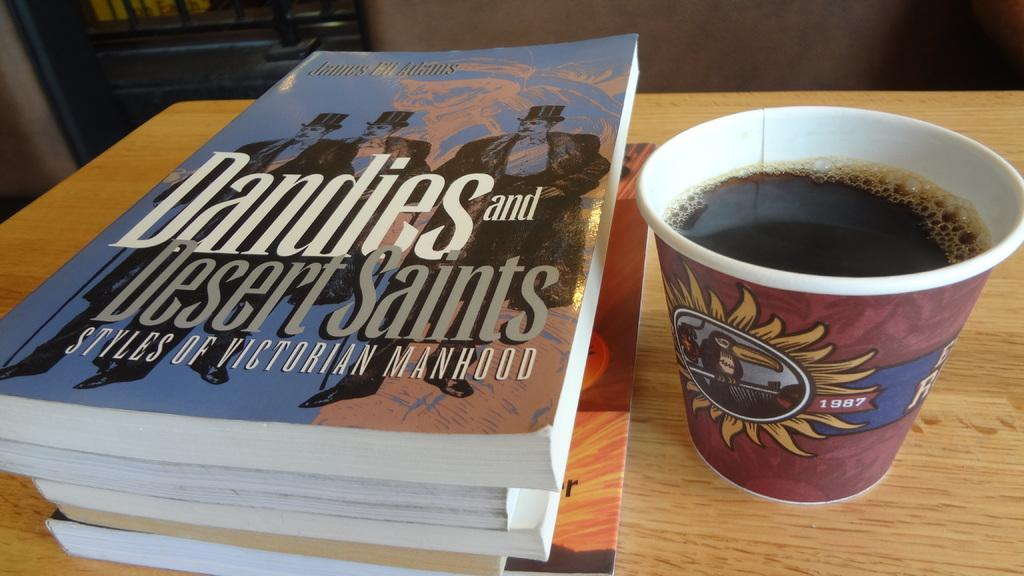<image>
Render a clear and concise summary of the photo. A book called dandies and desert saints next to a cup of coffee. 